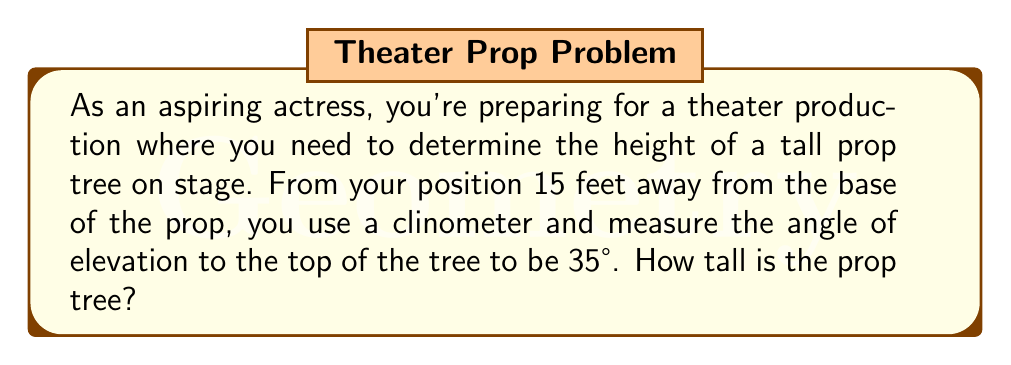Can you answer this question? Let's approach this step-by-step using trigonometry:

1) First, let's visualize the problem:

[asy]
import geometry;

size(200);

pair A = (0,0);
pair B = (15,0);
pair C = (0,10.5);

draw(A--B--C--A);

label("15 ft", (7.5,-0.5));
label("?", (-0.5,5));
label("35°", (1,0.5));

draw(rightangle(B,A,C,0.6));
[/asy]

2) We have a right triangle where:
   - The adjacent side is 15 feet (distance from you to the base of the tree)
   - The angle of elevation is 35°
   - We need to find the opposite side (height of the tree)

3) In this scenario, we should use the tangent ratio:

   $\tan \theta = \frac{\text{opposite}}{\text{adjacent}}$

4) Plugging in our known values:

   $\tan 35° = \frac{\text{height}}{15}$

5) To solve for the height, we multiply both sides by 15:

   $15 \cdot \tan 35° = \text{height}$

6) Now we can calculate:
   
   $\text{height} = 15 \cdot \tan 35°$
   
   $\text{height} = 15 \cdot 0.7002075$
   
   $\text{height} \approx 10.50$ feet

Therefore, the prop tree is approximately 10.50 feet tall.
Answer: The prop tree is approximately 10.50 feet tall. 